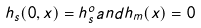<formula> <loc_0><loc_0><loc_500><loc_500>h _ { s } ( 0 , x ) = h _ { s } ^ { o } a n d h _ { m } ( x ) = 0</formula> 